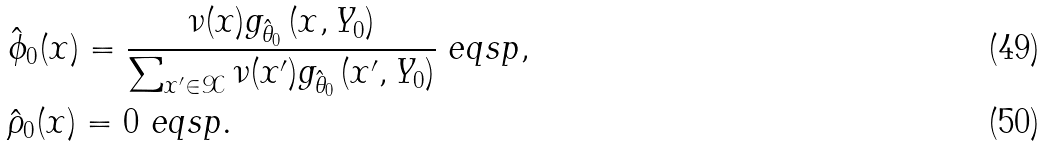Convert formula to latex. <formula><loc_0><loc_0><loc_500><loc_500>& \hat { \phi } _ { 0 } ( x ) = \frac { \nu ( x ) g _ { \hat { \theta } _ { 0 } } \, ( x , Y _ { 0 } ) } { \sum _ { x ^ { \prime } \in \mathcal { X } } \nu ( x ^ { \prime } ) g _ { \hat { \theta } _ { 0 } } \, ( x ^ { \prime } , Y _ { 0 } ) } \ e q s p , \\ & \hat { \rho } _ { 0 } ( x ) = 0 \ e q s p .</formula> 